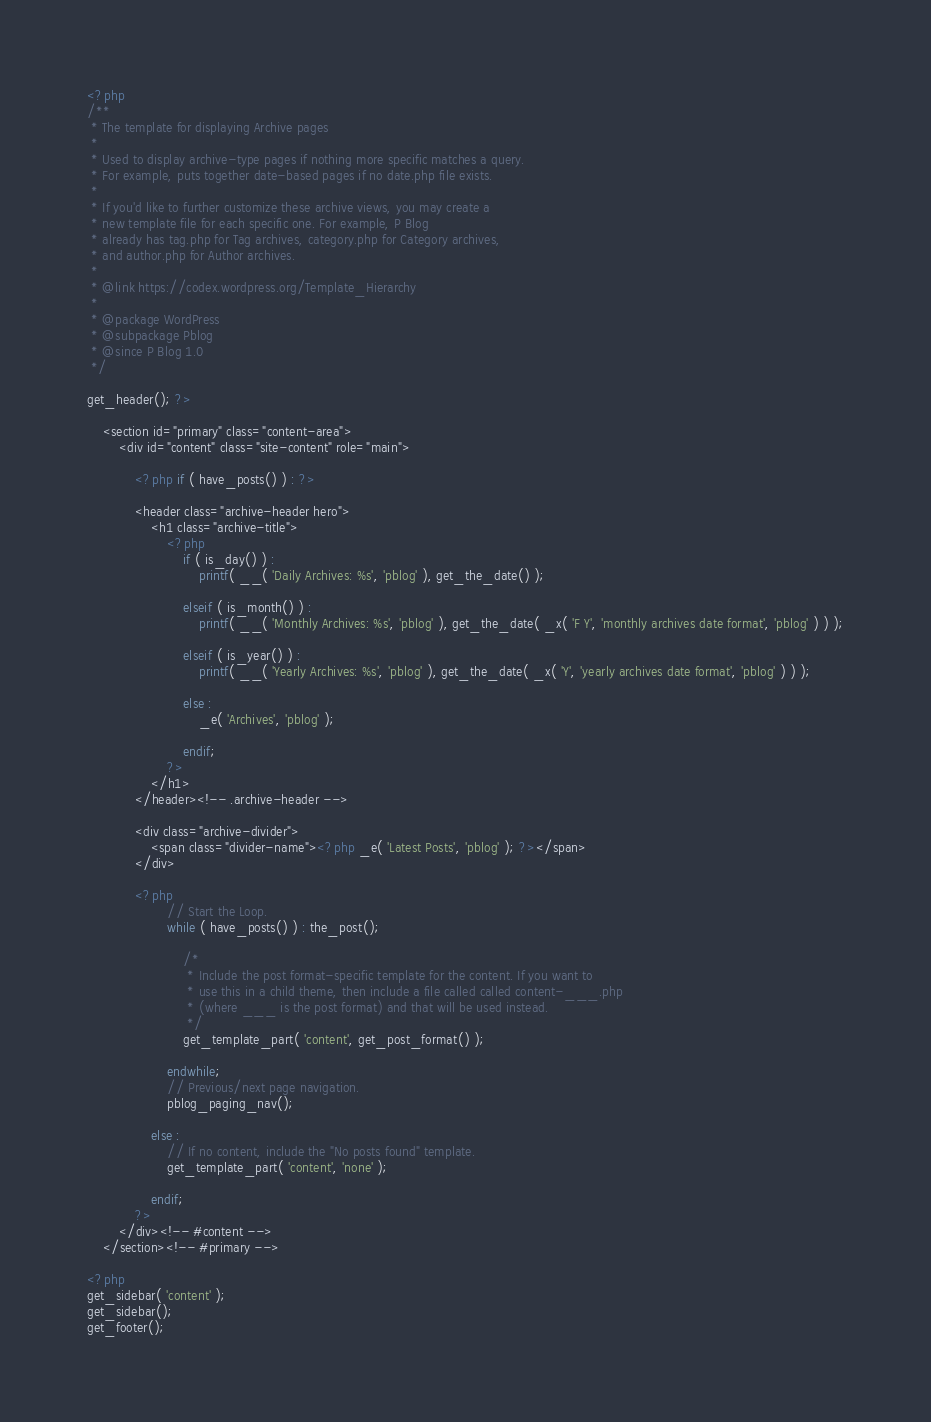Convert code to text. <code><loc_0><loc_0><loc_500><loc_500><_PHP_><?php
/**
 * The template for displaying Archive pages
 *
 * Used to display archive-type pages if nothing more specific matches a query.
 * For example, puts together date-based pages if no date.php file exists.
 *
 * If you'd like to further customize these archive views, you may create a
 * new template file for each specific one. For example, P Blog
 * already has tag.php for Tag archives, category.php for Category archives,
 * and author.php for Author archives.
 *
 * @link https://codex.wordpress.org/Template_Hierarchy
 *
 * @package WordPress
 * @subpackage Pblog
 * @since P Blog 1.0
 */

get_header(); ?>

	<section id="primary" class="content-area">
		<div id="content" class="site-content" role="main">

			<?php if ( have_posts() ) : ?>

			<header class="archive-header hero">
				<h1 class="archive-title">
					<?php
						if ( is_day() ) :
							printf( __( 'Daily Archives: %s', 'pblog' ), get_the_date() );

						elseif ( is_month() ) :
							printf( __( 'Monthly Archives: %s', 'pblog' ), get_the_date( _x( 'F Y', 'monthly archives date format', 'pblog' ) ) );

						elseif ( is_year() ) :
							printf( __( 'Yearly Archives: %s', 'pblog' ), get_the_date( _x( 'Y', 'yearly archives date format', 'pblog' ) ) );

						else :
							_e( 'Archives', 'pblog' );

						endif;
					?>
				</h1>
			</header><!-- .archive-header -->

			<div class="archive-divider">
				<span class="divider-name"><?php _e( 'Latest Posts', 'pblog' ); ?></span>
			</div>

			<?php
					// Start the Loop.
					while ( have_posts() ) : the_post();

						/*
						 * Include the post format-specific template for the content. If you want to
						 * use this in a child theme, then include a file called called content-___.php
						 * (where ___ is the post format) and that will be used instead.
						 */
						get_template_part( 'content', get_post_format() );

					endwhile;
					// Previous/next page navigation.
					pblog_paging_nav();

				else :
					// If no content, include the "No posts found" template.
					get_template_part( 'content', 'none' );

				endif;
			?>
		</div><!-- #content -->
	</section><!-- #primary -->

<?php
get_sidebar( 'content' );
get_sidebar();
get_footer();
</code> 